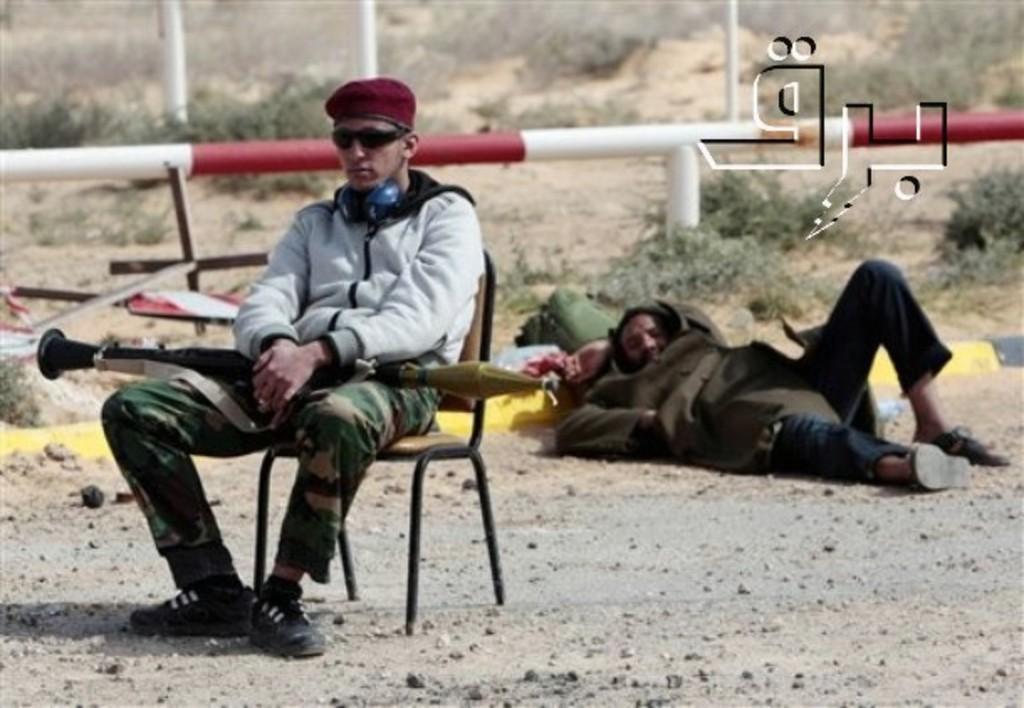Describe this image in one or two sentences. In this image there is a person sitting on the chair and he is holding some object. Behind him there is another person laying on the road. In the center of the image there is a rod. In the background of the image there are poles, plants. There are symbols on the right side of the image. 